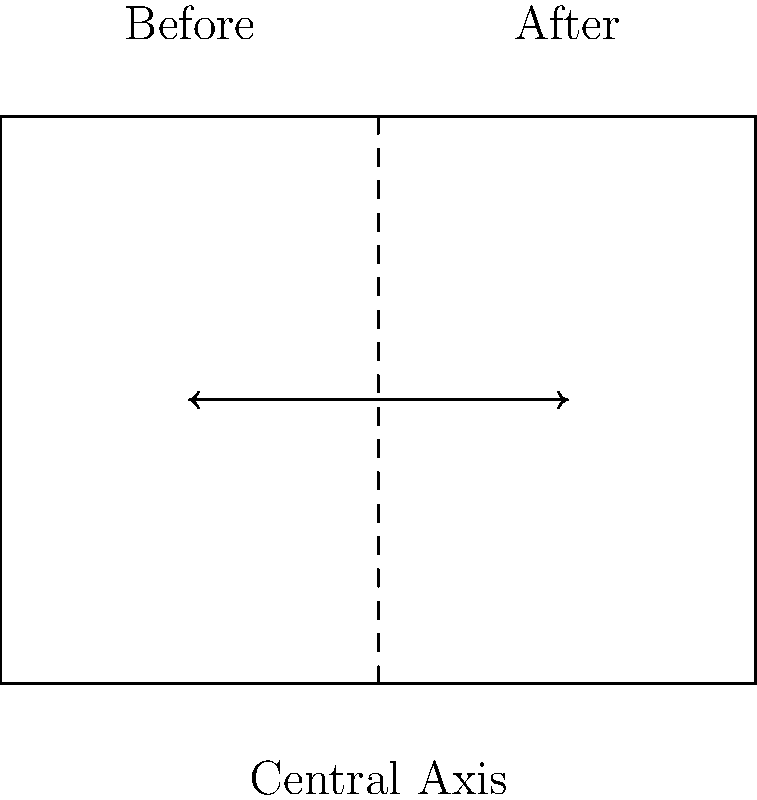As a transportation manager, you're tasked with balancing traffic congestion on a main road. The diagram shows the current traffic flow (left side) and the desired balanced flow (right side). If the reflection is performed across the central axis, what transformation matrix represents this reflection? To determine the transformation matrix for reflection across the central axis (vertical line), we can follow these steps:

1. The general matrix for reflection across the y-axis is:
   $$\begin{bmatrix} -1 & 0 \\ 0 & 1 \end{bmatrix}$$

2. However, our central axis is not at x = 0, but at x = 2. We need to:
   a) Translate the figure by -2 units in the x-direction
   b) Reflect across the y-axis
   c) Translate back by 2 units in the x-direction

3. The translation matrices are:
   $$T_{-2} = \begin{bmatrix} 1 & 0 \\ -2 & 1 \end{bmatrix}$$ and 
   $$T_{2} = \begin{bmatrix} 1 & 0 \\ 2 & 1 \end{bmatrix}$$

4. The complete transformation is:
   $$T_{2} \cdot \begin{bmatrix} -1 & 0 \\ 0 & 1 \end{bmatrix} \cdot T_{-2}$$

5. Multiplying these matrices:
   $$\begin{bmatrix} 1 & 0 \\ 2 & 1 \end{bmatrix} \cdot \begin{bmatrix} -1 & 0 \\ 0 & 1 \end{bmatrix} \cdot \begin{bmatrix} 1 & 0 \\ -2 & 1 \end{bmatrix}$$
   $$= \begin{bmatrix} -1 & 0 \\ 2 & 1 \end{bmatrix} \cdot \begin{bmatrix} 1 & 0 \\ -2 & 1 \end{bmatrix}$$
   $$= \begin{bmatrix} -1 & 0 \\ 4 & 1 \end{bmatrix}$$

Therefore, the transformation matrix for reflecting across the central axis at x = 2 is $$\begin{bmatrix} -1 & 0 \\ 4 & 1 \end{bmatrix}$$.
Answer: $$\begin{bmatrix} -1 & 0 \\ 4 & 1 \end{bmatrix}$$ 